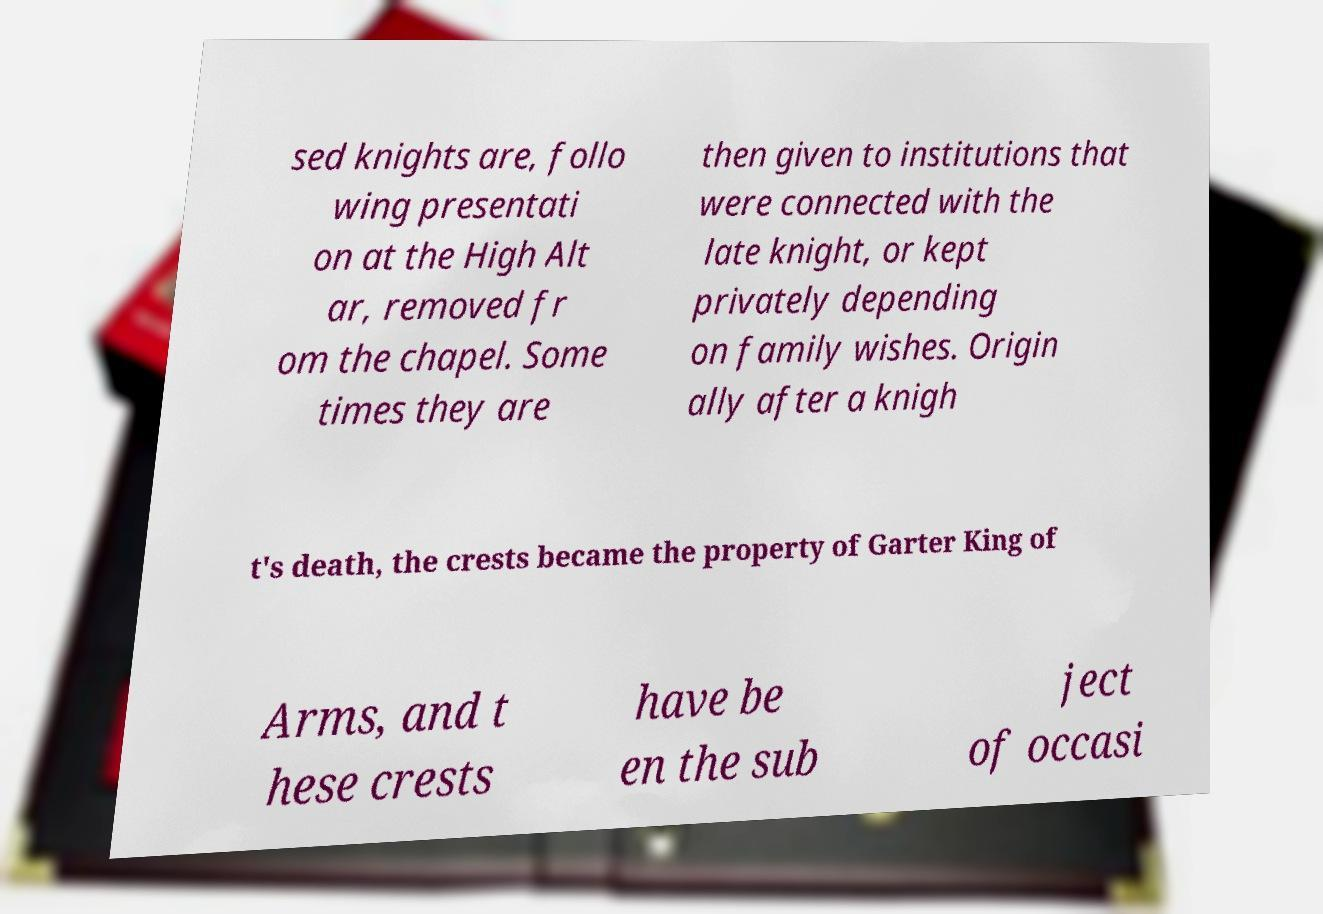For documentation purposes, I need the text within this image transcribed. Could you provide that? sed knights are, follo wing presentati on at the High Alt ar, removed fr om the chapel. Some times they are then given to institutions that were connected with the late knight, or kept privately depending on family wishes. Origin ally after a knigh t's death, the crests became the property of Garter King of Arms, and t hese crests have be en the sub ject of occasi 